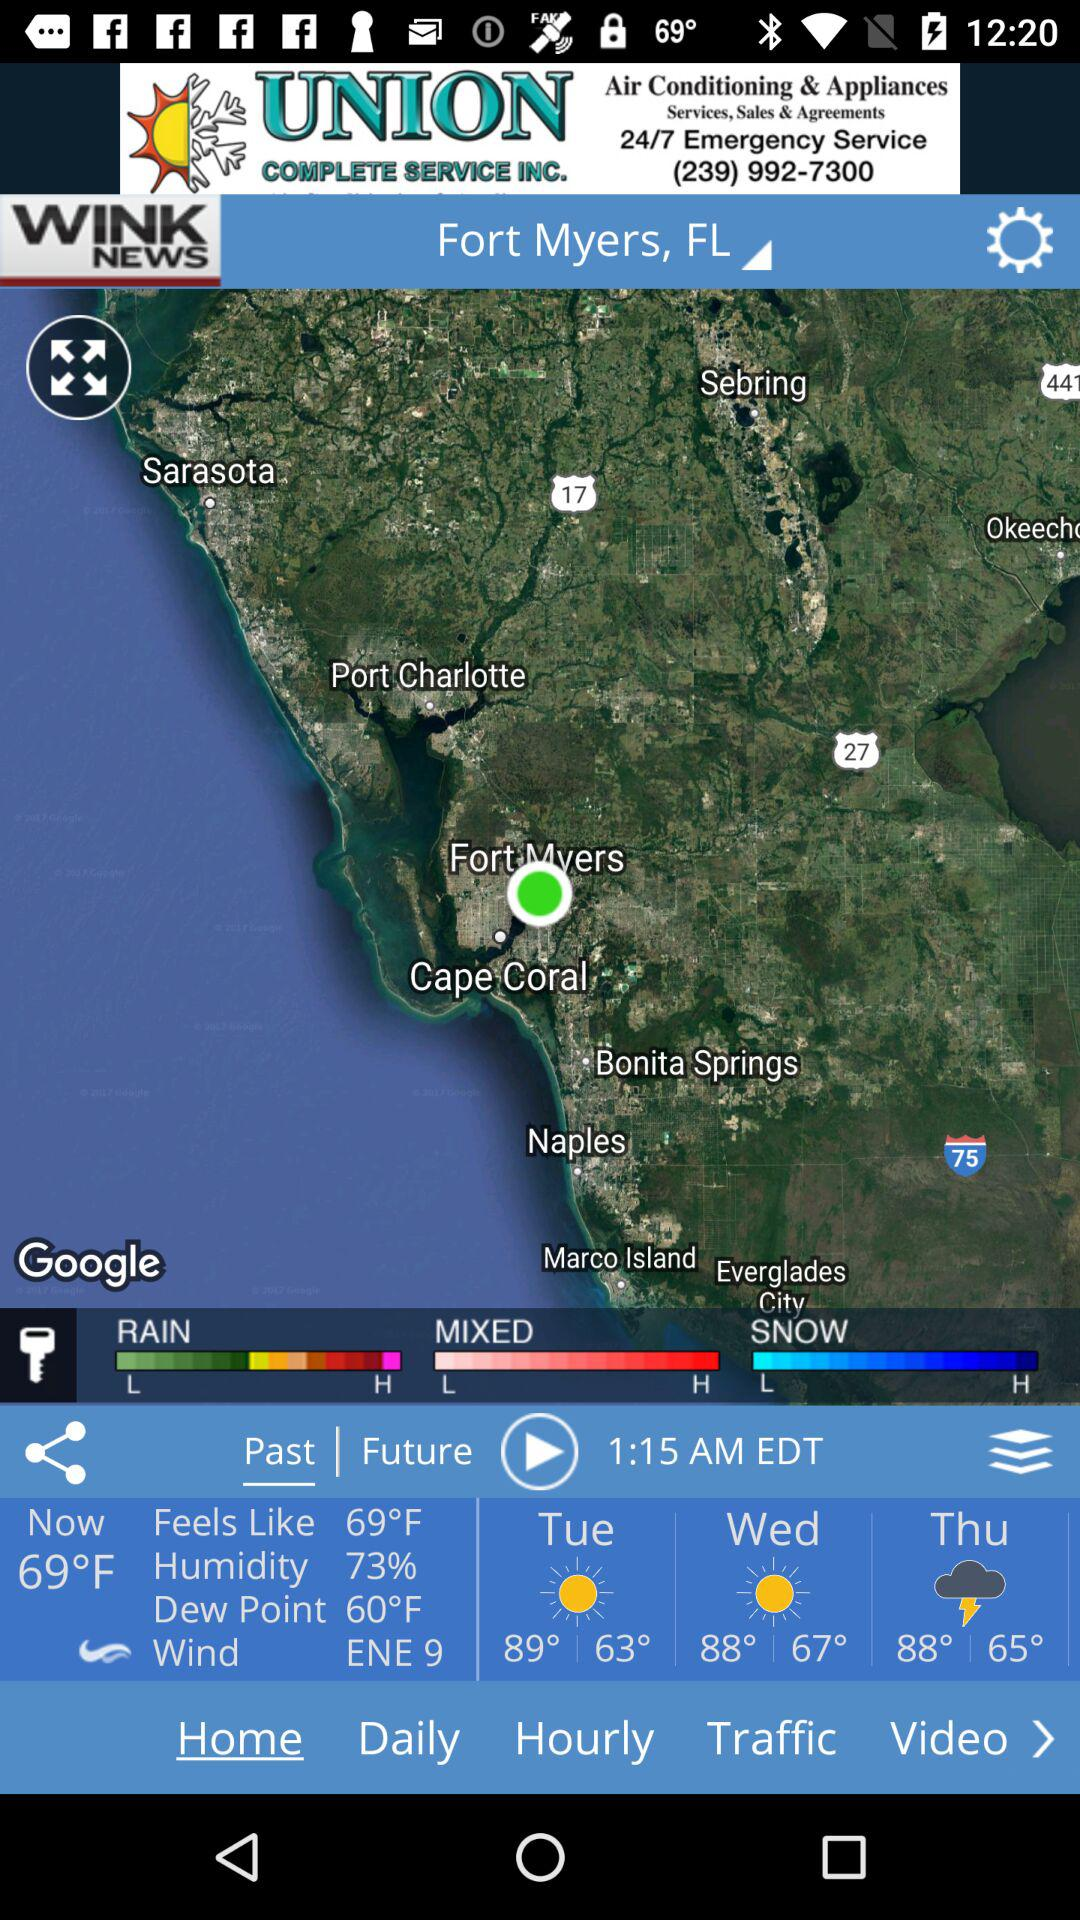What is the temperature for today?
Answer the question using a single word or phrase. 69°F 